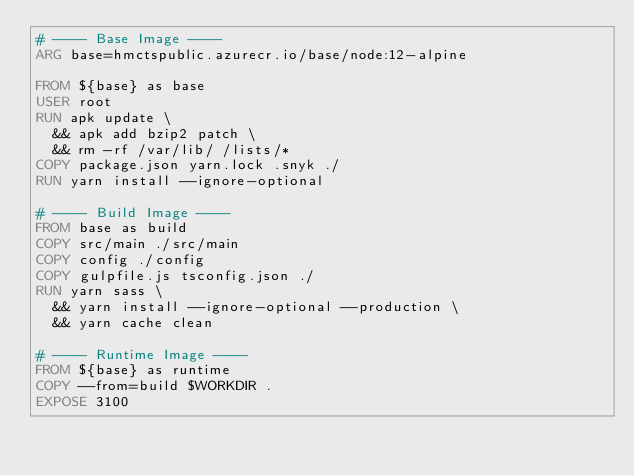Convert code to text. <code><loc_0><loc_0><loc_500><loc_500><_Dockerfile_># ---- Base Image ----
ARG base=hmctspublic.azurecr.io/base/node:12-alpine

FROM ${base} as base
USER root
RUN apk update \
  && apk add bzip2 patch \
  && rm -rf /var/lib/ /lists/*
COPY package.json yarn.lock .snyk ./
RUN yarn install --ignore-optional

# ---- Build Image ----
FROM base as build
COPY src/main ./src/main
COPY config ./config
COPY gulpfile.js tsconfig.json ./
RUN yarn sass \
  && yarn install --ignore-optional --production \
  && yarn cache clean

# ---- Runtime Image ----
FROM ${base} as runtime
COPY --from=build $WORKDIR .
EXPOSE 3100
</code> 